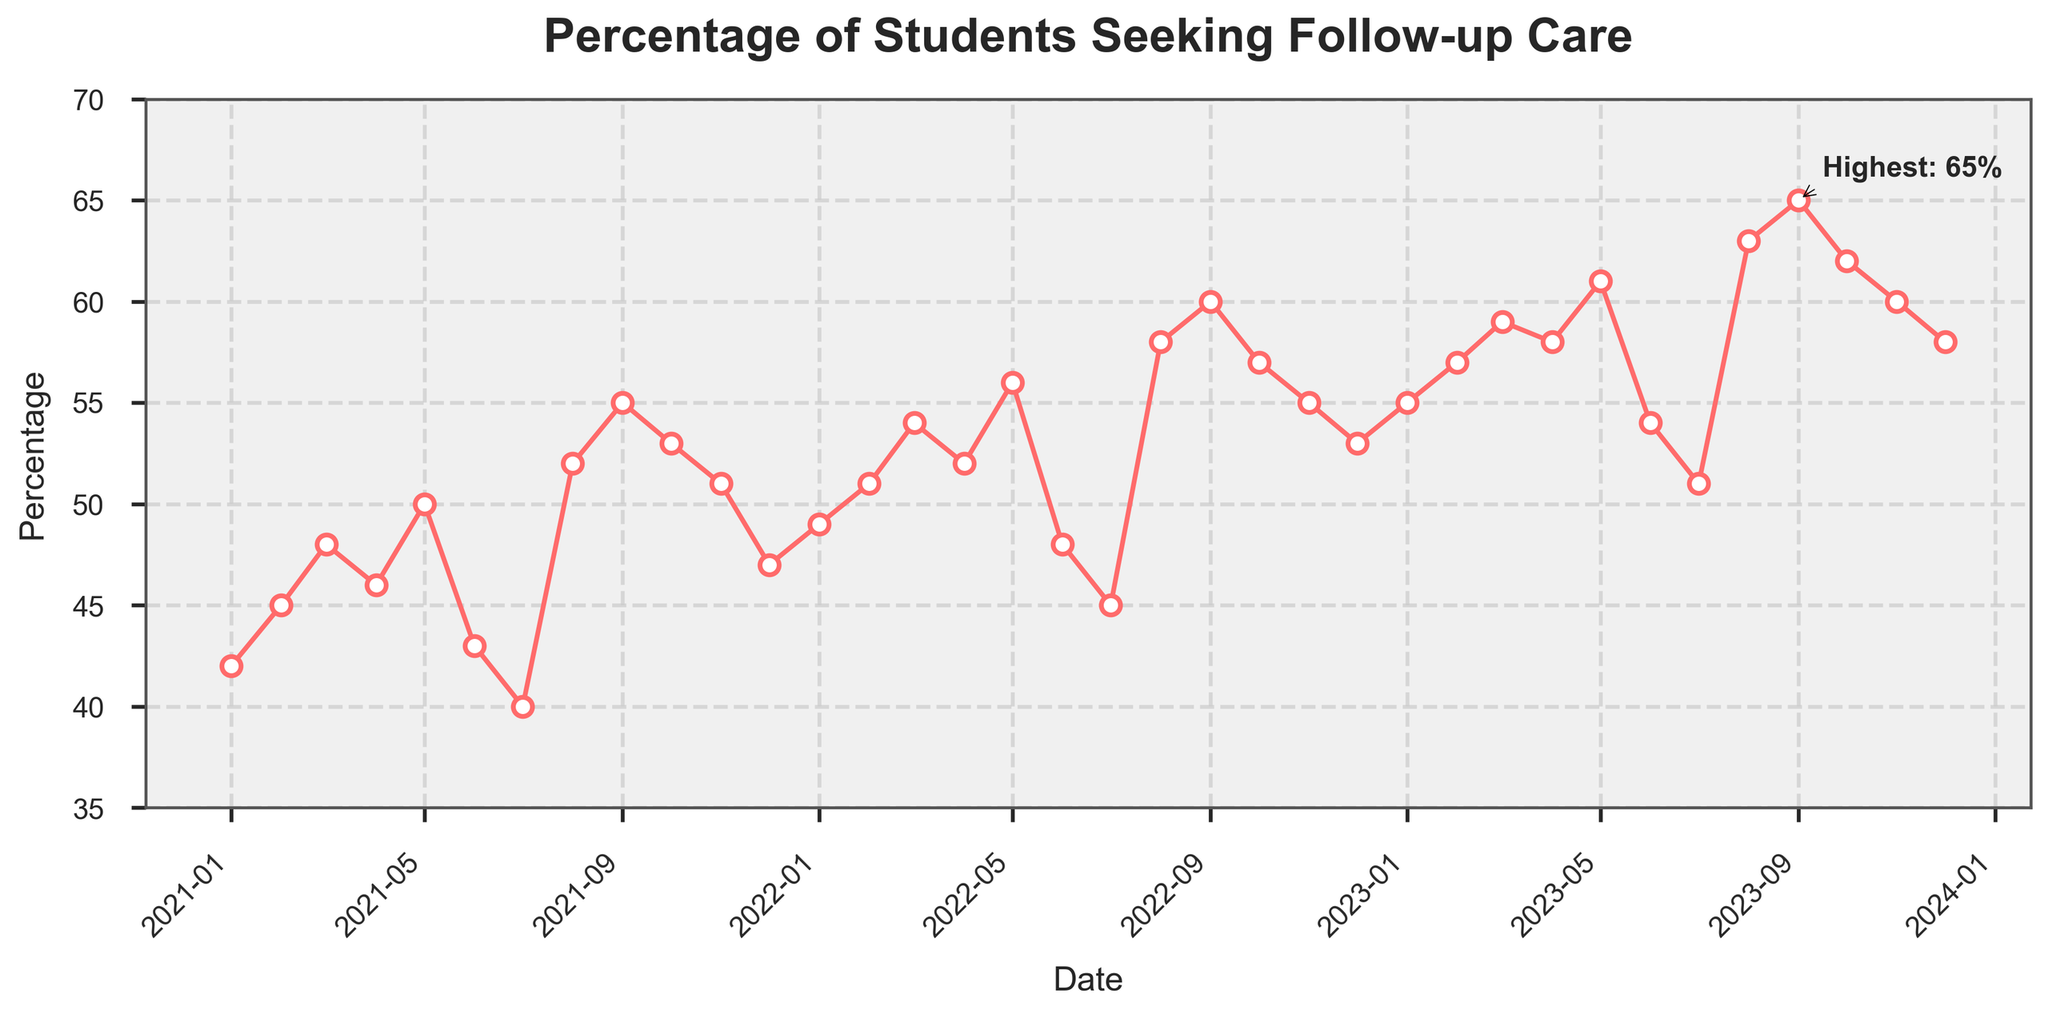What month and year had the highest percentage of students seeking follow-up care? According to the annotation on the chart, the highest percentage is marked. The label "Highest" points to a specific date and percentage value.
Answer: September 2023 How did the percentage change from January 2021 to December 2023? To find the percentage change, subtract the percentage of January 2021 from that of December 2023: 58 - 42 = 16%.
Answer: 16% Which year showed the greatest increase in the percentage of students seeking follow-up care compared to the previous year? By reviewing the data for each year: 
- From 2021 to 2022, the December values are 47 and 53, respectively, an increase of 6%.
- From 2022 to 2023, the December values are 53 and 58, respectively, an increase of 5%. 
The greatest increase happened from 2021 to 2022.
Answer: 2021 to 2022 Is there a noticeable seasonal trend in the percentage of follow-up care? To determine this, observe the chart for any repeating patterns across the same months in different years. Notable dips occur around June and July each year, suggesting a seasonal trend.
Answer: Yes What was the difference in percentage between the highest month and the lowest month in 2021? Identify the highest and lowest percentages in 2021: highest in September 55%, lowest in July 40%. Difference: 55 - 40 = 15%.
Answer: 15% Which month usually has the lowest percentage of follow-up care? By observing the pattern across the three years, July consistently shows one of the lower percentages each year (40% in 2021, 45% in 2022, 51% in 2023).
Answer: July How did the percentage in December 2023 compare to that in May 2023? Look at both points on the chart: May 2023 had 61%, and December 2023 had 58%.
Answer: 3% decrease Were there any months where the percentage decreased consecutively? Search for trends where the line goes downward over consecutive months. For instance, in 2021, the percentages decrease consecutively from October 53% to December 47%.
Answer: October to December 2021 What is the average percentage of students seeking follow-up care in 2022? Sum the percentages for each month in 2022 and divide by 12: 
(49 + 51 + 54 + 52 + 56 + 48 + 45 + 58 + 60 + 57 + 55 + 53) / 12 = 54.
Answer: 54 